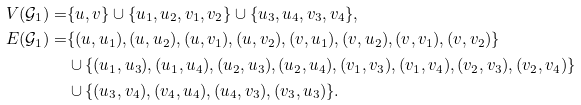<formula> <loc_0><loc_0><loc_500><loc_500>V ( \mathcal { G } _ { 1 } ) = & \{ u , v \} \cup \{ u _ { 1 } , u _ { 2 } , v _ { 1 } , v _ { 2 } \} \cup \{ u _ { 3 } , u _ { 4 } , v _ { 3 } , v _ { 4 } \} , \\ E ( \mathcal { G } _ { 1 } ) = & \{ ( u , u _ { 1 } ) , ( u , u _ { 2 } ) , ( u , v _ { 1 } ) , ( u , v _ { 2 } ) , ( v , u _ { 1 } ) , ( v , u _ { 2 } ) , ( v , v _ { 1 } ) , ( v , v _ { 2 } ) \} \\ & \cup \{ ( u _ { 1 } , u _ { 3 } ) , ( u _ { 1 } , u _ { 4 } ) , ( u _ { 2 } , u _ { 3 } ) , ( u _ { 2 } , u _ { 4 } ) , ( v _ { 1 } , v _ { 3 } ) , ( v _ { 1 } , v _ { 4 } ) , ( v _ { 2 } , v _ { 3 } ) , ( v _ { 2 } , v _ { 4 } ) \} \\ & \cup \{ ( u _ { 3 } , v _ { 4 } ) , ( v _ { 4 } , u _ { 4 } ) , ( u _ { 4 } , v _ { 3 } ) , ( v _ { 3 } , u _ { 3 } ) \} .</formula> 